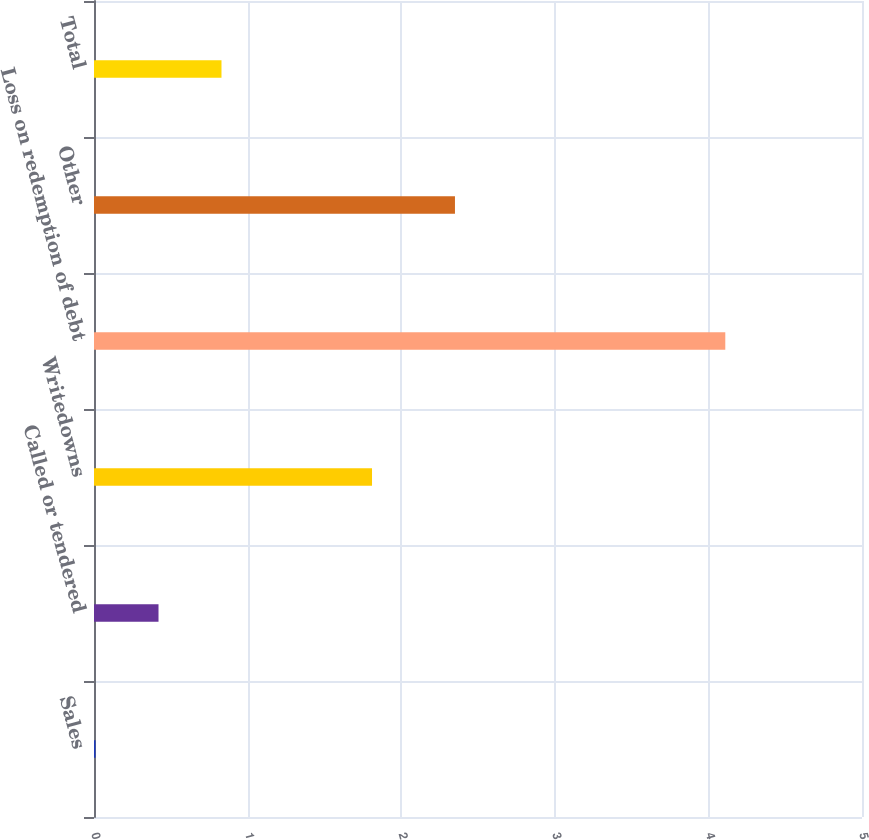Convert chart. <chart><loc_0><loc_0><loc_500><loc_500><bar_chart><fcel>Sales<fcel>Called or tendered<fcel>Writedowns<fcel>Loss on redemption of debt<fcel>Other<fcel>Total<nl><fcel>0.01<fcel>0.42<fcel>1.81<fcel>4.11<fcel>2.35<fcel>0.83<nl></chart> 